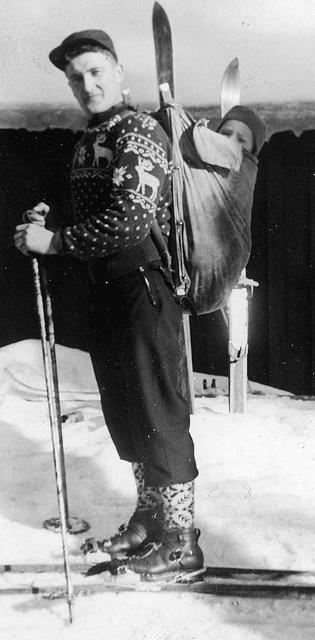What relation is the man to the boy in his backpack?

Choices:
A) pastor
B) neighbor
C) teacher
D) father father 